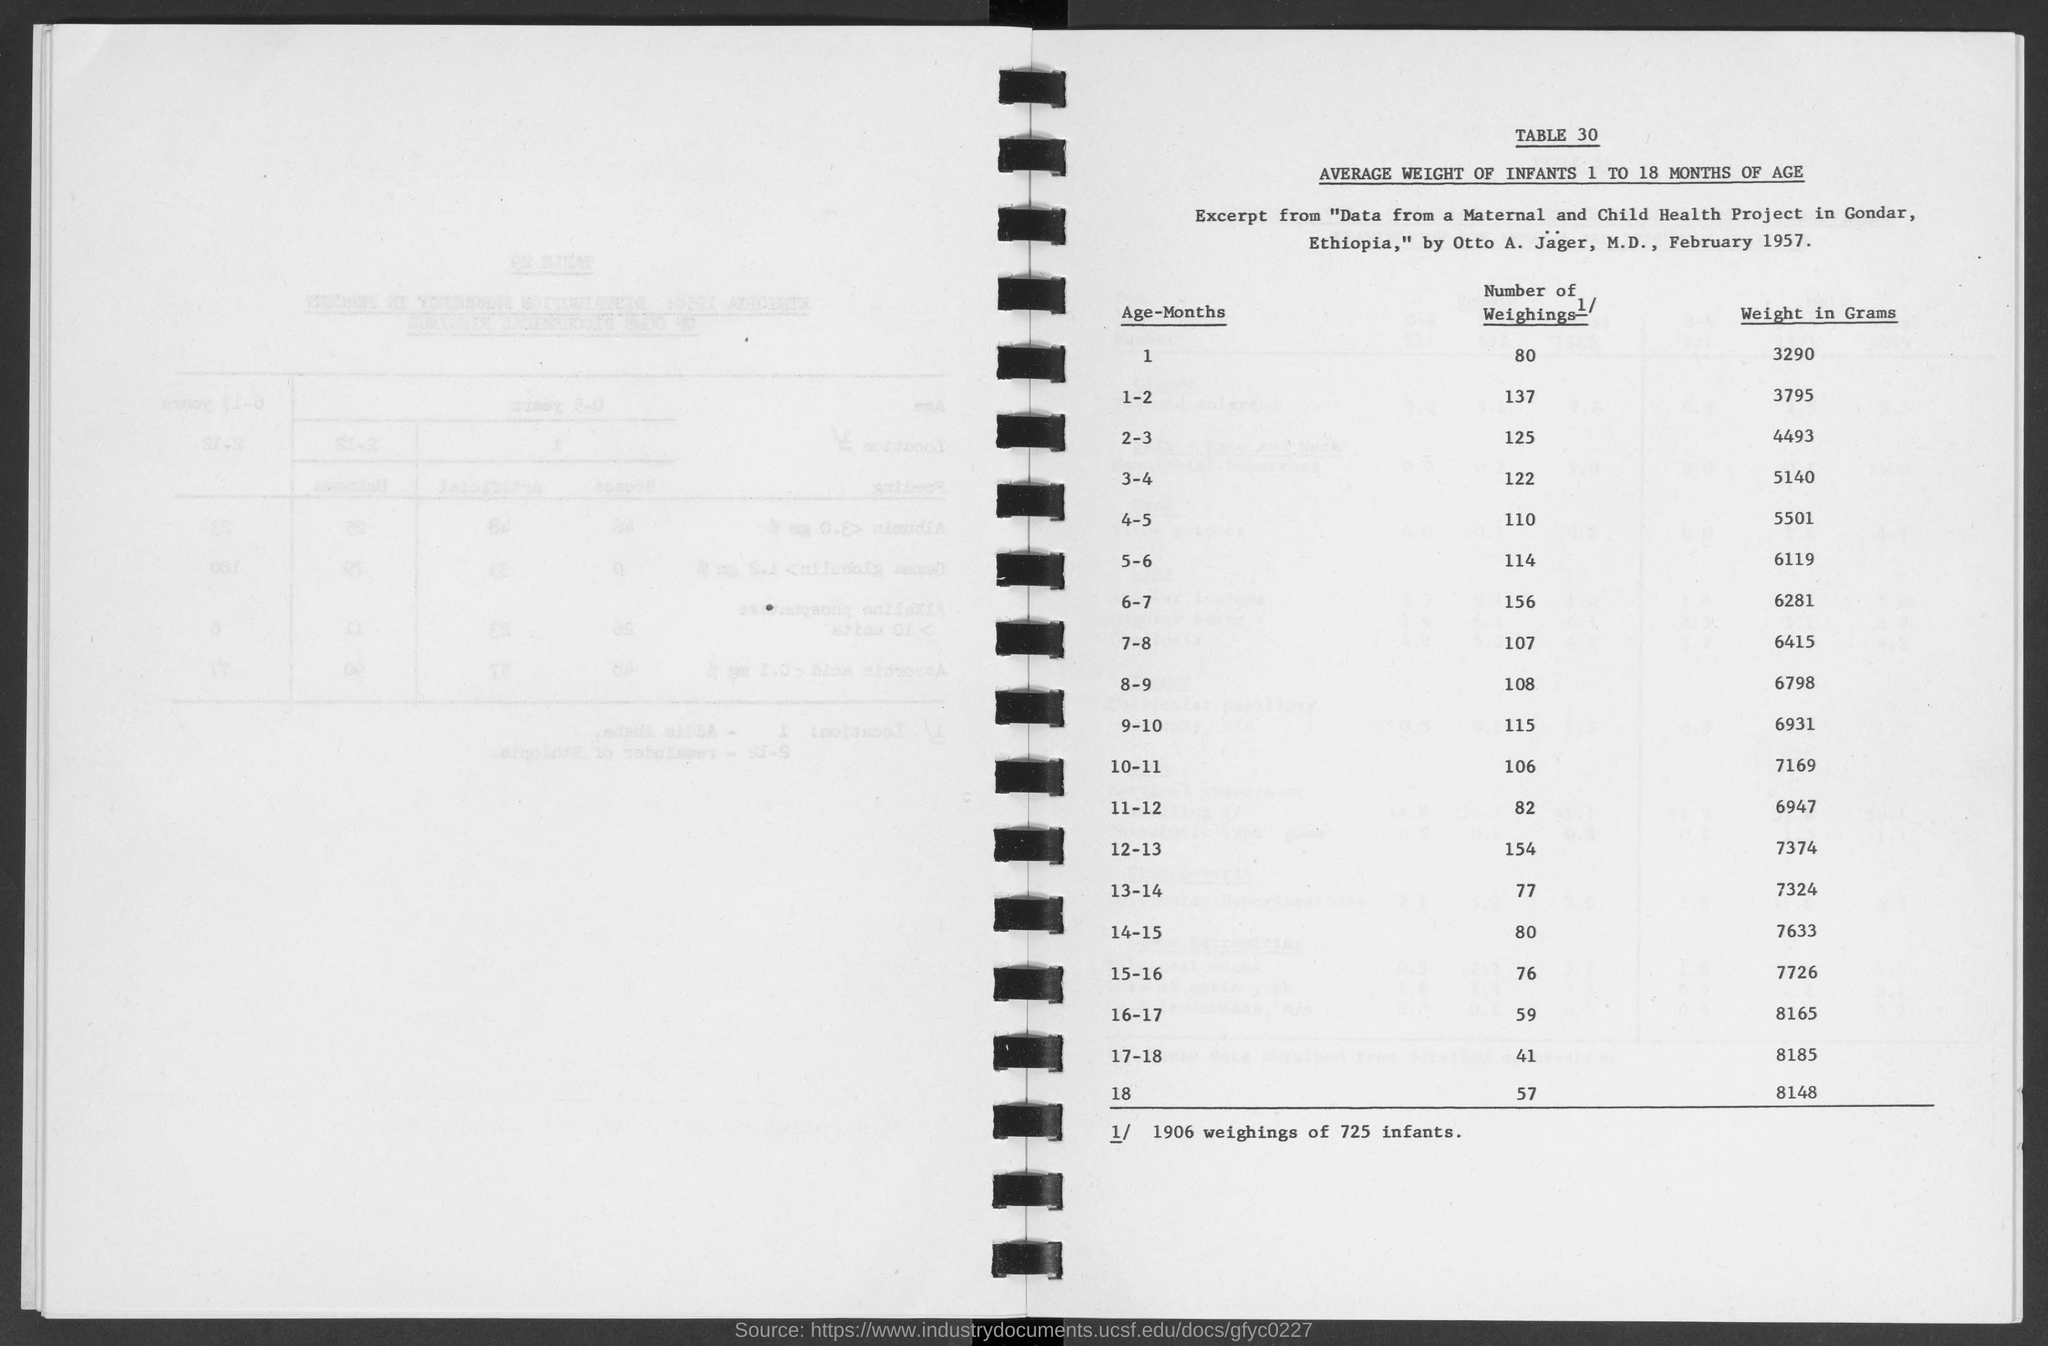What is the title of TABLE 30 given in the document?
Give a very brief answer. AVERAGE WEIGHT OF INFANTS 1 TO 18 MONTHS OF AGE. What is the average weight in grams for infants in the age group 2-3?
Offer a terse response. 4493. What is the average weight in grams for infants in the age group 5-6?
Keep it short and to the point. 6119. What is the number of weighings for infants in the age group 1-2?
Give a very brief answer. 137. What is the number of weighings for infants in the age group 7-8?
Your answer should be very brief. 107. What is the average weight in grams for infants in the age group 11-12?
Give a very brief answer. 6947. What is the number of weighings for infants in the age group 5-6?
Provide a succinct answer. 114. 